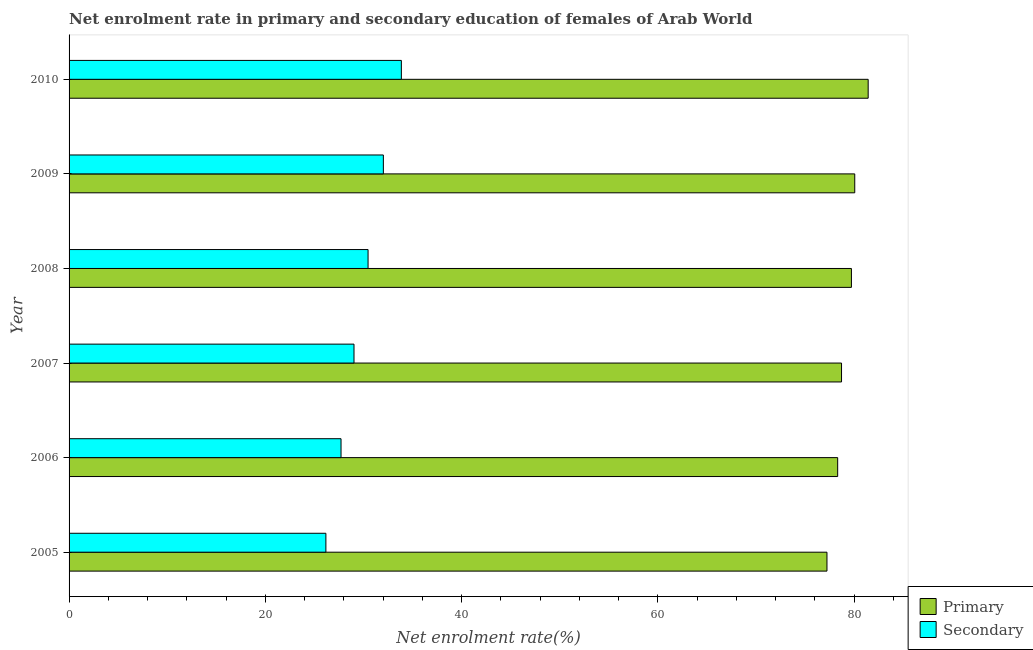Are the number of bars per tick equal to the number of legend labels?
Your response must be concise. Yes. How many bars are there on the 5th tick from the top?
Ensure brevity in your answer.  2. How many bars are there on the 5th tick from the bottom?
Your answer should be very brief. 2. What is the enrollment rate in secondary education in 2005?
Your response must be concise. 26.17. Across all years, what is the maximum enrollment rate in secondary education?
Provide a short and direct response. 33.86. Across all years, what is the minimum enrollment rate in secondary education?
Provide a short and direct response. 26.17. In which year was the enrollment rate in primary education maximum?
Offer a very short reply. 2010. What is the total enrollment rate in secondary education in the graph?
Ensure brevity in your answer.  179.29. What is the difference between the enrollment rate in secondary education in 2005 and that in 2010?
Keep it short and to the point. -7.69. What is the difference between the enrollment rate in secondary education in 2006 and the enrollment rate in primary education in 2010?
Offer a terse response. -53.72. What is the average enrollment rate in secondary education per year?
Ensure brevity in your answer.  29.88. In the year 2008, what is the difference between the enrollment rate in primary education and enrollment rate in secondary education?
Offer a terse response. 49.26. What is the ratio of the enrollment rate in secondary education in 2005 to that in 2007?
Ensure brevity in your answer.  0.9. Is the difference between the enrollment rate in primary education in 2008 and 2010 greater than the difference between the enrollment rate in secondary education in 2008 and 2010?
Your answer should be very brief. Yes. What is the difference between the highest and the second highest enrollment rate in primary education?
Offer a very short reply. 1.37. What is the difference between the highest and the lowest enrollment rate in primary education?
Keep it short and to the point. 4.2. In how many years, is the enrollment rate in primary education greater than the average enrollment rate in primary education taken over all years?
Make the answer very short. 3. Is the sum of the enrollment rate in secondary education in 2007 and 2008 greater than the maximum enrollment rate in primary education across all years?
Provide a succinct answer. No. What does the 1st bar from the top in 2006 represents?
Offer a terse response. Secondary. What does the 2nd bar from the bottom in 2009 represents?
Your answer should be very brief. Secondary. Are all the bars in the graph horizontal?
Your answer should be compact. Yes. How many years are there in the graph?
Your response must be concise. 6. Are the values on the major ticks of X-axis written in scientific E-notation?
Your response must be concise. No. Does the graph contain any zero values?
Keep it short and to the point. No. How are the legend labels stacked?
Provide a short and direct response. Vertical. What is the title of the graph?
Offer a very short reply. Net enrolment rate in primary and secondary education of females of Arab World. What is the label or title of the X-axis?
Keep it short and to the point. Net enrolment rate(%). What is the Net enrolment rate(%) of Primary in 2005?
Your answer should be very brief. 77.24. What is the Net enrolment rate(%) of Secondary in 2005?
Provide a succinct answer. 26.17. What is the Net enrolment rate(%) of Primary in 2006?
Your response must be concise. 78.33. What is the Net enrolment rate(%) in Secondary in 2006?
Give a very brief answer. 27.72. What is the Net enrolment rate(%) of Primary in 2007?
Your response must be concise. 78.72. What is the Net enrolment rate(%) of Secondary in 2007?
Your answer should be very brief. 29.04. What is the Net enrolment rate(%) of Primary in 2008?
Keep it short and to the point. 79.73. What is the Net enrolment rate(%) in Secondary in 2008?
Provide a short and direct response. 30.47. What is the Net enrolment rate(%) in Primary in 2009?
Make the answer very short. 80.07. What is the Net enrolment rate(%) of Secondary in 2009?
Provide a short and direct response. 32.03. What is the Net enrolment rate(%) in Primary in 2010?
Ensure brevity in your answer.  81.44. What is the Net enrolment rate(%) of Secondary in 2010?
Provide a succinct answer. 33.86. Across all years, what is the maximum Net enrolment rate(%) in Primary?
Ensure brevity in your answer.  81.44. Across all years, what is the maximum Net enrolment rate(%) in Secondary?
Offer a terse response. 33.86. Across all years, what is the minimum Net enrolment rate(%) in Primary?
Provide a succinct answer. 77.24. Across all years, what is the minimum Net enrolment rate(%) in Secondary?
Provide a succinct answer. 26.17. What is the total Net enrolment rate(%) in Primary in the graph?
Ensure brevity in your answer.  475.53. What is the total Net enrolment rate(%) in Secondary in the graph?
Your response must be concise. 179.29. What is the difference between the Net enrolment rate(%) of Primary in 2005 and that in 2006?
Provide a short and direct response. -1.09. What is the difference between the Net enrolment rate(%) in Secondary in 2005 and that in 2006?
Your response must be concise. -1.54. What is the difference between the Net enrolment rate(%) of Primary in 2005 and that in 2007?
Your response must be concise. -1.48. What is the difference between the Net enrolment rate(%) of Secondary in 2005 and that in 2007?
Your answer should be compact. -2.86. What is the difference between the Net enrolment rate(%) of Primary in 2005 and that in 2008?
Provide a short and direct response. -2.49. What is the difference between the Net enrolment rate(%) of Secondary in 2005 and that in 2008?
Give a very brief answer. -4.3. What is the difference between the Net enrolment rate(%) of Primary in 2005 and that in 2009?
Provide a short and direct response. -2.83. What is the difference between the Net enrolment rate(%) in Secondary in 2005 and that in 2009?
Provide a succinct answer. -5.86. What is the difference between the Net enrolment rate(%) in Primary in 2005 and that in 2010?
Your answer should be very brief. -4.2. What is the difference between the Net enrolment rate(%) of Secondary in 2005 and that in 2010?
Offer a very short reply. -7.69. What is the difference between the Net enrolment rate(%) of Primary in 2006 and that in 2007?
Your answer should be compact. -0.39. What is the difference between the Net enrolment rate(%) in Secondary in 2006 and that in 2007?
Your response must be concise. -1.32. What is the difference between the Net enrolment rate(%) of Primary in 2006 and that in 2008?
Your answer should be very brief. -1.4. What is the difference between the Net enrolment rate(%) in Secondary in 2006 and that in 2008?
Your answer should be compact. -2.75. What is the difference between the Net enrolment rate(%) in Primary in 2006 and that in 2009?
Ensure brevity in your answer.  -1.74. What is the difference between the Net enrolment rate(%) in Secondary in 2006 and that in 2009?
Ensure brevity in your answer.  -4.31. What is the difference between the Net enrolment rate(%) in Primary in 2006 and that in 2010?
Provide a succinct answer. -3.11. What is the difference between the Net enrolment rate(%) of Secondary in 2006 and that in 2010?
Offer a terse response. -6.15. What is the difference between the Net enrolment rate(%) of Primary in 2007 and that in 2008?
Provide a short and direct response. -1.01. What is the difference between the Net enrolment rate(%) of Secondary in 2007 and that in 2008?
Your response must be concise. -1.43. What is the difference between the Net enrolment rate(%) of Primary in 2007 and that in 2009?
Your answer should be compact. -1.35. What is the difference between the Net enrolment rate(%) in Secondary in 2007 and that in 2009?
Provide a short and direct response. -2.99. What is the difference between the Net enrolment rate(%) in Primary in 2007 and that in 2010?
Your answer should be very brief. -2.72. What is the difference between the Net enrolment rate(%) in Secondary in 2007 and that in 2010?
Make the answer very short. -4.83. What is the difference between the Net enrolment rate(%) in Primary in 2008 and that in 2009?
Your response must be concise. -0.34. What is the difference between the Net enrolment rate(%) in Secondary in 2008 and that in 2009?
Your response must be concise. -1.56. What is the difference between the Net enrolment rate(%) in Primary in 2008 and that in 2010?
Your answer should be compact. -1.71. What is the difference between the Net enrolment rate(%) of Secondary in 2008 and that in 2010?
Your answer should be very brief. -3.39. What is the difference between the Net enrolment rate(%) in Primary in 2009 and that in 2010?
Your answer should be very brief. -1.37. What is the difference between the Net enrolment rate(%) of Secondary in 2009 and that in 2010?
Make the answer very short. -1.83. What is the difference between the Net enrolment rate(%) in Primary in 2005 and the Net enrolment rate(%) in Secondary in 2006?
Provide a short and direct response. 49.52. What is the difference between the Net enrolment rate(%) in Primary in 2005 and the Net enrolment rate(%) in Secondary in 2007?
Provide a short and direct response. 48.2. What is the difference between the Net enrolment rate(%) of Primary in 2005 and the Net enrolment rate(%) of Secondary in 2008?
Your answer should be very brief. 46.77. What is the difference between the Net enrolment rate(%) in Primary in 2005 and the Net enrolment rate(%) in Secondary in 2009?
Keep it short and to the point. 45.21. What is the difference between the Net enrolment rate(%) in Primary in 2005 and the Net enrolment rate(%) in Secondary in 2010?
Ensure brevity in your answer.  43.38. What is the difference between the Net enrolment rate(%) of Primary in 2006 and the Net enrolment rate(%) of Secondary in 2007?
Offer a terse response. 49.29. What is the difference between the Net enrolment rate(%) in Primary in 2006 and the Net enrolment rate(%) in Secondary in 2008?
Give a very brief answer. 47.86. What is the difference between the Net enrolment rate(%) in Primary in 2006 and the Net enrolment rate(%) in Secondary in 2009?
Your answer should be compact. 46.3. What is the difference between the Net enrolment rate(%) of Primary in 2006 and the Net enrolment rate(%) of Secondary in 2010?
Keep it short and to the point. 44.47. What is the difference between the Net enrolment rate(%) of Primary in 2007 and the Net enrolment rate(%) of Secondary in 2008?
Offer a terse response. 48.25. What is the difference between the Net enrolment rate(%) in Primary in 2007 and the Net enrolment rate(%) in Secondary in 2009?
Provide a succinct answer. 46.69. What is the difference between the Net enrolment rate(%) of Primary in 2007 and the Net enrolment rate(%) of Secondary in 2010?
Offer a terse response. 44.86. What is the difference between the Net enrolment rate(%) in Primary in 2008 and the Net enrolment rate(%) in Secondary in 2009?
Provide a succinct answer. 47.7. What is the difference between the Net enrolment rate(%) in Primary in 2008 and the Net enrolment rate(%) in Secondary in 2010?
Provide a short and direct response. 45.87. What is the difference between the Net enrolment rate(%) in Primary in 2009 and the Net enrolment rate(%) in Secondary in 2010?
Give a very brief answer. 46.21. What is the average Net enrolment rate(%) in Primary per year?
Offer a terse response. 79.26. What is the average Net enrolment rate(%) of Secondary per year?
Make the answer very short. 29.88. In the year 2005, what is the difference between the Net enrolment rate(%) in Primary and Net enrolment rate(%) in Secondary?
Offer a very short reply. 51.07. In the year 2006, what is the difference between the Net enrolment rate(%) in Primary and Net enrolment rate(%) in Secondary?
Your answer should be very brief. 50.61. In the year 2007, what is the difference between the Net enrolment rate(%) in Primary and Net enrolment rate(%) in Secondary?
Provide a succinct answer. 49.69. In the year 2008, what is the difference between the Net enrolment rate(%) of Primary and Net enrolment rate(%) of Secondary?
Offer a very short reply. 49.26. In the year 2009, what is the difference between the Net enrolment rate(%) in Primary and Net enrolment rate(%) in Secondary?
Your response must be concise. 48.04. In the year 2010, what is the difference between the Net enrolment rate(%) of Primary and Net enrolment rate(%) of Secondary?
Give a very brief answer. 47.57. What is the ratio of the Net enrolment rate(%) of Primary in 2005 to that in 2006?
Your response must be concise. 0.99. What is the ratio of the Net enrolment rate(%) in Secondary in 2005 to that in 2006?
Offer a terse response. 0.94. What is the ratio of the Net enrolment rate(%) of Primary in 2005 to that in 2007?
Your answer should be very brief. 0.98. What is the ratio of the Net enrolment rate(%) in Secondary in 2005 to that in 2007?
Ensure brevity in your answer.  0.9. What is the ratio of the Net enrolment rate(%) of Primary in 2005 to that in 2008?
Keep it short and to the point. 0.97. What is the ratio of the Net enrolment rate(%) in Secondary in 2005 to that in 2008?
Your answer should be compact. 0.86. What is the ratio of the Net enrolment rate(%) in Primary in 2005 to that in 2009?
Offer a very short reply. 0.96. What is the ratio of the Net enrolment rate(%) in Secondary in 2005 to that in 2009?
Provide a short and direct response. 0.82. What is the ratio of the Net enrolment rate(%) of Primary in 2005 to that in 2010?
Ensure brevity in your answer.  0.95. What is the ratio of the Net enrolment rate(%) of Secondary in 2005 to that in 2010?
Your answer should be very brief. 0.77. What is the ratio of the Net enrolment rate(%) of Primary in 2006 to that in 2007?
Give a very brief answer. 0.99. What is the ratio of the Net enrolment rate(%) in Secondary in 2006 to that in 2007?
Give a very brief answer. 0.95. What is the ratio of the Net enrolment rate(%) in Primary in 2006 to that in 2008?
Ensure brevity in your answer.  0.98. What is the ratio of the Net enrolment rate(%) in Secondary in 2006 to that in 2008?
Your answer should be very brief. 0.91. What is the ratio of the Net enrolment rate(%) in Primary in 2006 to that in 2009?
Provide a short and direct response. 0.98. What is the ratio of the Net enrolment rate(%) of Secondary in 2006 to that in 2009?
Provide a succinct answer. 0.87. What is the ratio of the Net enrolment rate(%) in Primary in 2006 to that in 2010?
Offer a very short reply. 0.96. What is the ratio of the Net enrolment rate(%) in Secondary in 2006 to that in 2010?
Provide a succinct answer. 0.82. What is the ratio of the Net enrolment rate(%) of Primary in 2007 to that in 2008?
Your answer should be very brief. 0.99. What is the ratio of the Net enrolment rate(%) of Secondary in 2007 to that in 2008?
Ensure brevity in your answer.  0.95. What is the ratio of the Net enrolment rate(%) of Primary in 2007 to that in 2009?
Your response must be concise. 0.98. What is the ratio of the Net enrolment rate(%) in Secondary in 2007 to that in 2009?
Keep it short and to the point. 0.91. What is the ratio of the Net enrolment rate(%) of Primary in 2007 to that in 2010?
Offer a very short reply. 0.97. What is the ratio of the Net enrolment rate(%) in Secondary in 2007 to that in 2010?
Offer a terse response. 0.86. What is the ratio of the Net enrolment rate(%) of Primary in 2008 to that in 2009?
Ensure brevity in your answer.  1. What is the ratio of the Net enrolment rate(%) of Secondary in 2008 to that in 2009?
Offer a very short reply. 0.95. What is the ratio of the Net enrolment rate(%) of Secondary in 2008 to that in 2010?
Give a very brief answer. 0.9. What is the ratio of the Net enrolment rate(%) of Primary in 2009 to that in 2010?
Keep it short and to the point. 0.98. What is the ratio of the Net enrolment rate(%) in Secondary in 2009 to that in 2010?
Keep it short and to the point. 0.95. What is the difference between the highest and the second highest Net enrolment rate(%) of Primary?
Offer a very short reply. 1.37. What is the difference between the highest and the second highest Net enrolment rate(%) of Secondary?
Your response must be concise. 1.83. What is the difference between the highest and the lowest Net enrolment rate(%) of Primary?
Provide a short and direct response. 4.2. What is the difference between the highest and the lowest Net enrolment rate(%) of Secondary?
Provide a short and direct response. 7.69. 